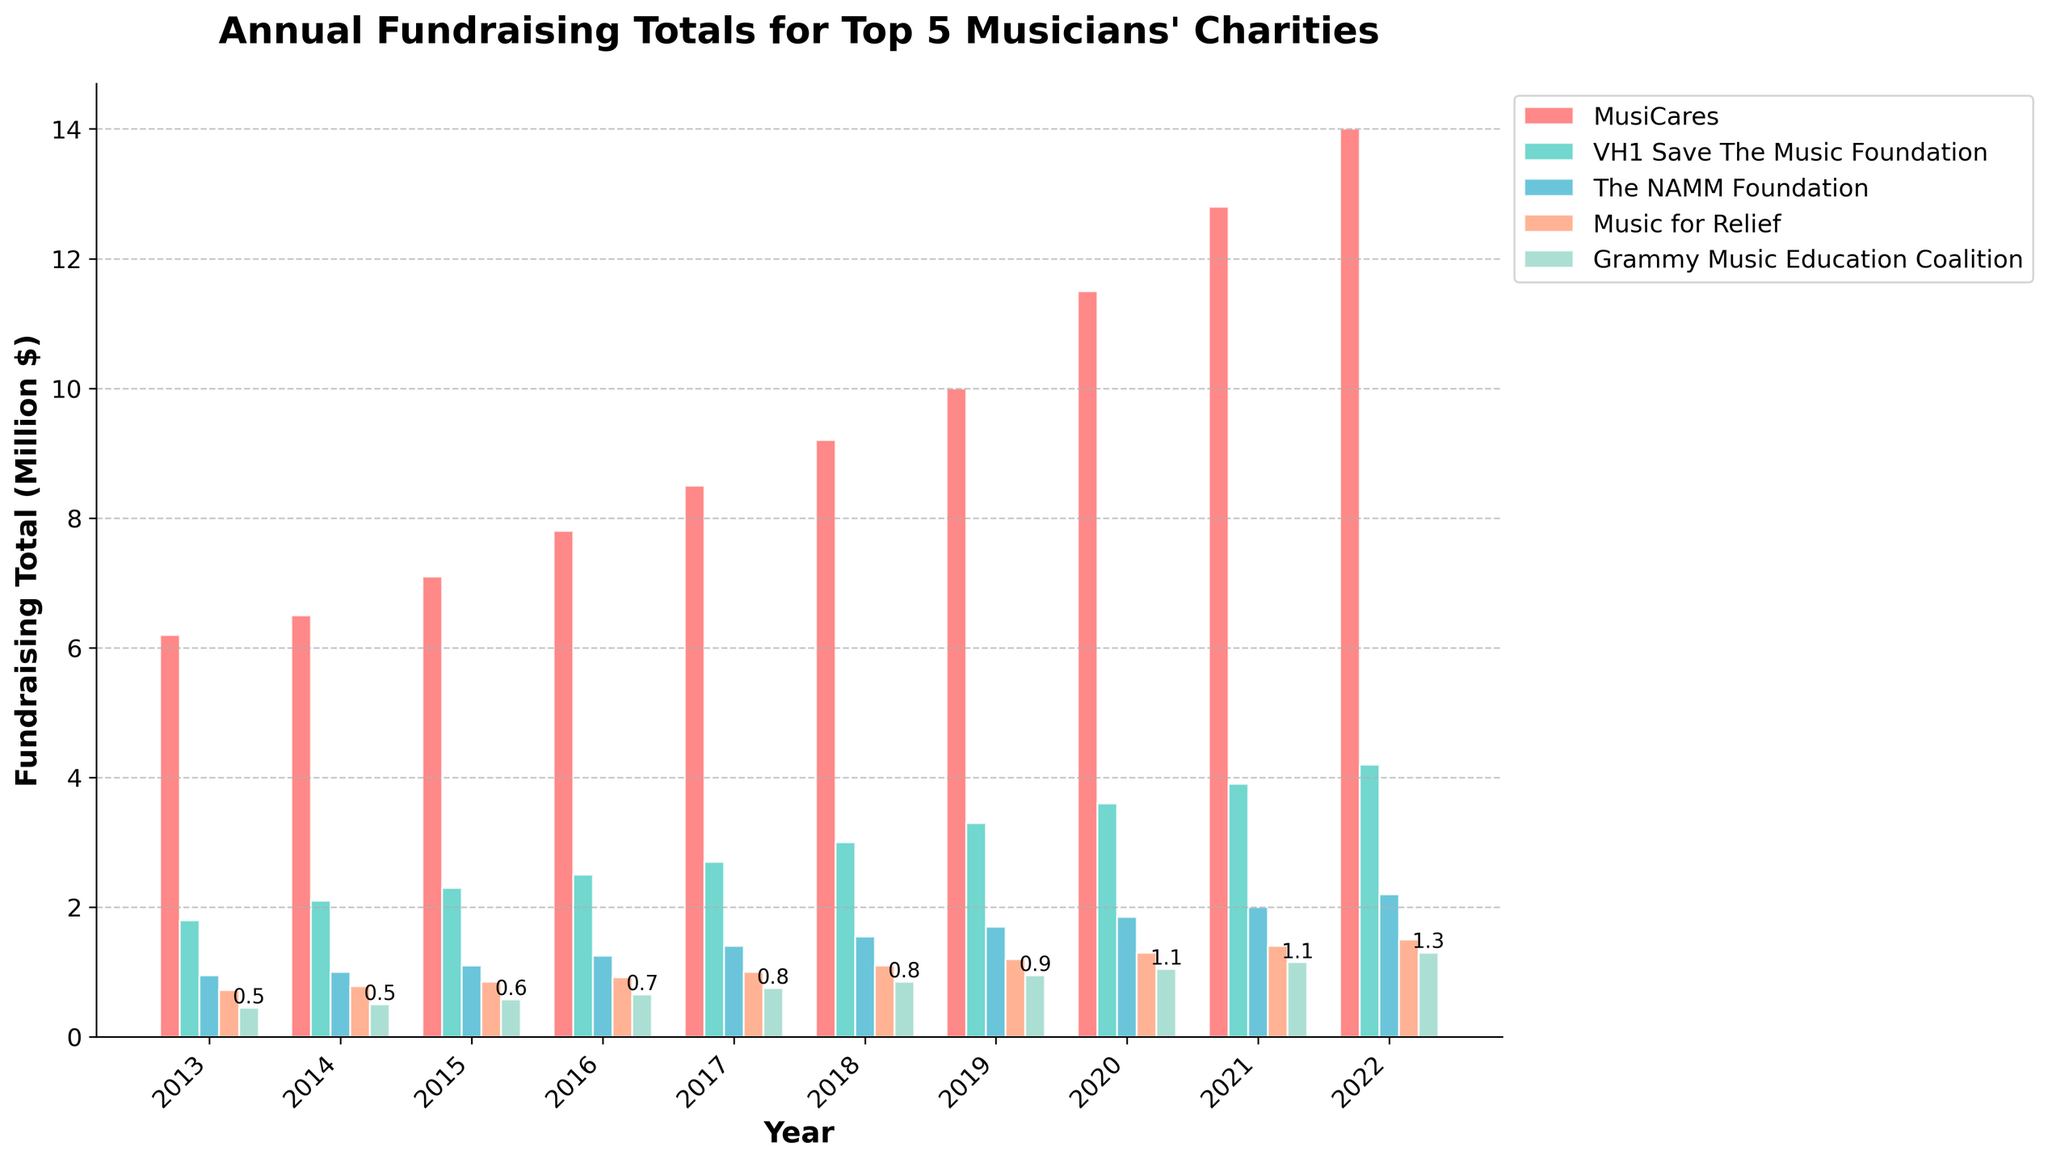what is the highest fundraising total for MusiCares? Identify the bar corresponding to MusiCares with the highest height. The highest bar indicates the highest fundraising total for MusiCares in the year 2022 with a total of $14,000,000.
Answer: $14,000,000 Which year did VH1 Save The Music Foundation surpass 3 million dollars? Look for bars representing VH1 Save The Music Foundation and identify the year when the bar height first surpasses the 3 million mark. In this case, it occurred in 2018.
Answer: 2018 Which charity consistently increased their funds over the decade? Identify bars for each charity across each year and observe which charity has bars continuously increasing in height without any drops. VH1 Save The Music Foundation, MusiCares, and The NAMM Foundation all consistently increased their funds each year.
Answer: VH1 Save The Music Foundation, MusiCares, The NAMM Foundation Which year had the smallest difference between the top two charities' fundraising totals? Compare the heights of the top two bars (MusiCares and VH1 Save The Music Foundation) for each year and calculate the differences. The smallest difference was in 2022, where MusiCares raised $14,000,000 and VH1 Save The Music Foundation raised $4,200,000, resulting in a difference of $9,800,000.
Answer: 2022 What is the average fundraising total for Music for Relief from 2013 to 2022? Add up the yearly totals for Music for Relief over the given years and divide by the number of years. (720,000 + 780,000 + 850,000 + 920,000 + 1,000,000 + 1,100,000 + 1,200,000 + 1,300,000 + 1,400,000 + 1,500,000) / 10 = 1,077,000.
Answer: $1,077,000 Which charities had their highest fundraising total in 2020? Identify bars for the year 2020 for each charity and note if they are the highest compared to other years. MusiCares had its highest total in 2020 up to that year but continued increasing in subsequent years.
Answer: None Did Grammy Music Education Coalition ever double its fundraising amount in any given year compared to the previous year? Compare the height of bars representing Grammy Music Education Coalition for each year, checking if any year’s total is at least twice the previous year's total. This didn't occur in any of the given years.
Answer: No Which charity had the smallest growth in fundraising total from 2013 to 2022? Calculate the difference in fundraising totals between 2013 and 2022 for each charity and identify the smallest growth. Grammy Music Education Coalition had the smallest growth, increasing by $850,000 - $450,000 = $400,000.
Answer: Grammy Music Education Coalition 